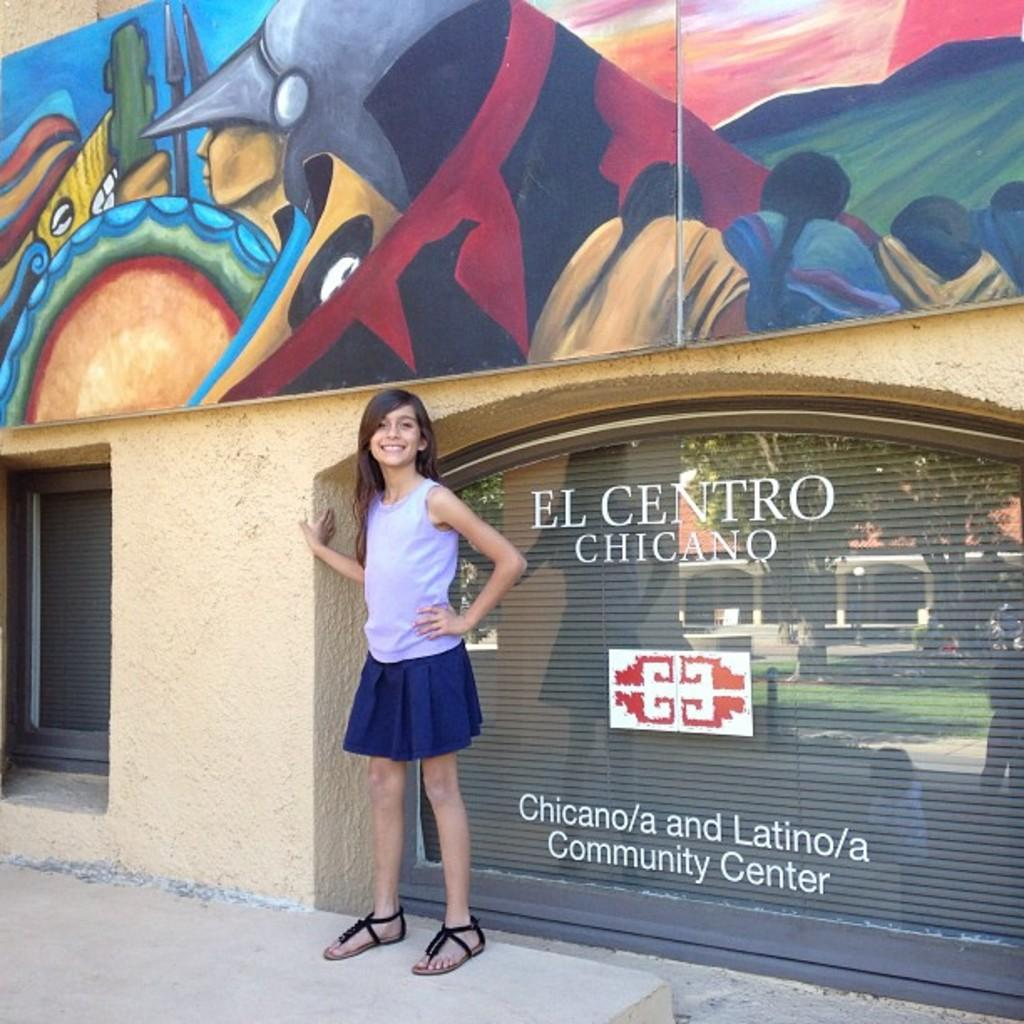<image>
Offer a succinct explanation of the picture presented. A girl is standing in front of a community center window. 